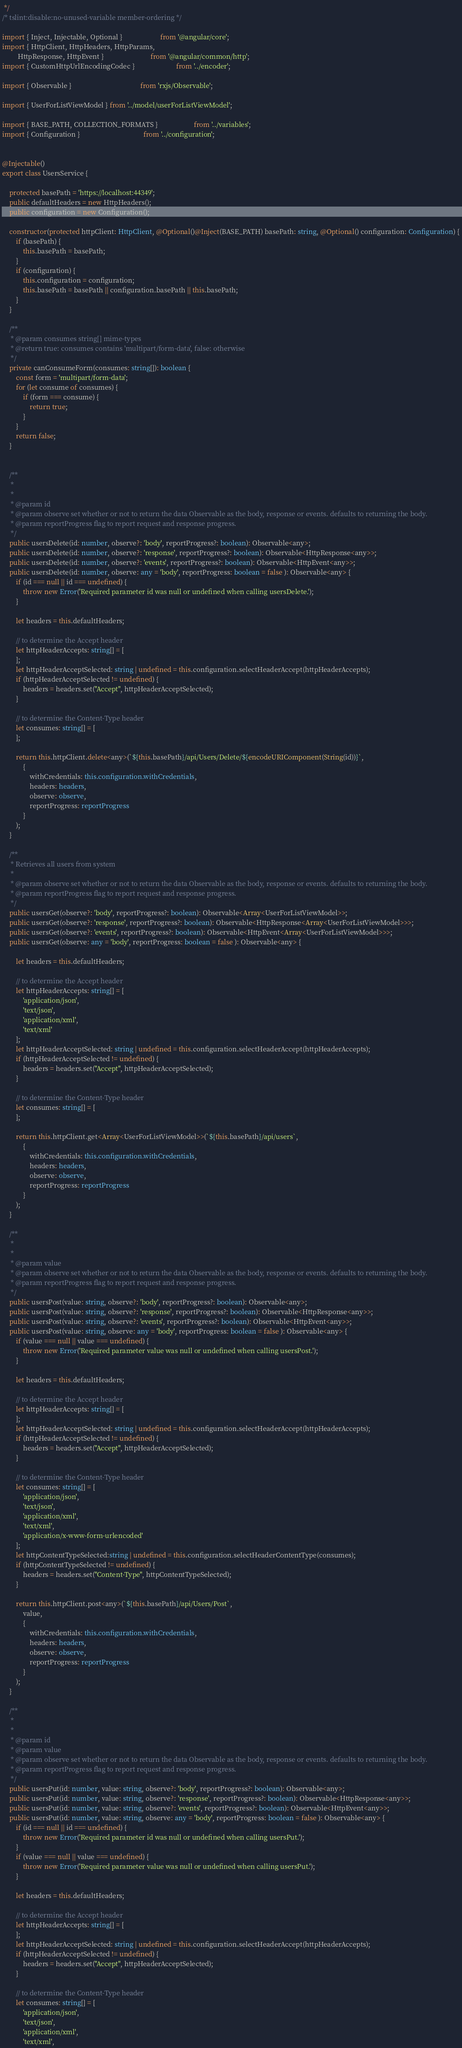Convert code to text. <code><loc_0><loc_0><loc_500><loc_500><_TypeScript_> */
/* tslint:disable:no-unused-variable member-ordering */

import { Inject, Injectable, Optional }                      from '@angular/core';
import { HttpClient, HttpHeaders, HttpParams,
         HttpResponse, HttpEvent }                           from '@angular/common/http';
import { CustomHttpUrlEncodingCodec }                        from '../encoder';

import { Observable }                                        from 'rxjs/Observable';

import { UserForListViewModel } from '../model/userForListViewModel';

import { BASE_PATH, COLLECTION_FORMATS }                     from '../variables';
import { Configuration }                                     from '../configuration';


@Injectable()
export class UsersService {

    protected basePath = 'https://localhost:44349';
    public defaultHeaders = new HttpHeaders();
    public configuration = new Configuration();

    constructor(protected httpClient: HttpClient, @Optional()@Inject(BASE_PATH) basePath: string, @Optional() configuration: Configuration) {
        if (basePath) {
            this.basePath = basePath;
        }
        if (configuration) {
            this.configuration = configuration;
            this.basePath = basePath || configuration.basePath || this.basePath;
        }
    }

    /**
     * @param consumes string[] mime-types
     * @return true: consumes contains 'multipart/form-data', false: otherwise
     */
    private canConsumeForm(consumes: string[]): boolean {
        const form = 'multipart/form-data';
        for (let consume of consumes) {
            if (form === consume) {
                return true;
            }
        }
        return false;
    }


    /**
     * 
     * 
     * @param id 
     * @param observe set whether or not to return the data Observable as the body, response or events. defaults to returning the body.
     * @param reportProgress flag to report request and response progress.
     */
    public usersDelete(id: number, observe?: 'body', reportProgress?: boolean): Observable<any>;
    public usersDelete(id: number, observe?: 'response', reportProgress?: boolean): Observable<HttpResponse<any>>;
    public usersDelete(id: number, observe?: 'events', reportProgress?: boolean): Observable<HttpEvent<any>>;
    public usersDelete(id: number, observe: any = 'body', reportProgress: boolean = false ): Observable<any> {
        if (id === null || id === undefined) {
            throw new Error('Required parameter id was null or undefined when calling usersDelete.');
        }

        let headers = this.defaultHeaders;

        // to determine the Accept header
        let httpHeaderAccepts: string[] = [
        ];
        let httpHeaderAcceptSelected: string | undefined = this.configuration.selectHeaderAccept(httpHeaderAccepts);
        if (httpHeaderAcceptSelected != undefined) {
            headers = headers.set("Accept", httpHeaderAcceptSelected);
        }

        // to determine the Content-Type header
        let consumes: string[] = [
        ];

        return this.httpClient.delete<any>(`${this.basePath}/api/Users/Delete/${encodeURIComponent(String(id))}`,
            {
                withCredentials: this.configuration.withCredentials,
                headers: headers,
                observe: observe,
                reportProgress: reportProgress
            }
        );
    }

    /**
     * Retrieves all users from system
     * 
     * @param observe set whether or not to return the data Observable as the body, response or events. defaults to returning the body.
     * @param reportProgress flag to report request and response progress.
     */
    public usersGet(observe?: 'body', reportProgress?: boolean): Observable<Array<UserForListViewModel>>;
    public usersGet(observe?: 'response', reportProgress?: boolean): Observable<HttpResponse<Array<UserForListViewModel>>>;
    public usersGet(observe?: 'events', reportProgress?: boolean): Observable<HttpEvent<Array<UserForListViewModel>>>;
    public usersGet(observe: any = 'body', reportProgress: boolean = false ): Observable<any> {

        let headers = this.defaultHeaders;

        // to determine the Accept header
        let httpHeaderAccepts: string[] = [
            'application/json',
            'text/json',
            'application/xml',
            'text/xml'
        ];
        let httpHeaderAcceptSelected: string | undefined = this.configuration.selectHeaderAccept(httpHeaderAccepts);
        if (httpHeaderAcceptSelected != undefined) {
            headers = headers.set("Accept", httpHeaderAcceptSelected);
        }

        // to determine the Content-Type header
        let consumes: string[] = [
        ];

        return this.httpClient.get<Array<UserForListViewModel>>(`${this.basePath}/api/users`,
            {
                withCredentials: this.configuration.withCredentials,
                headers: headers,
                observe: observe,
                reportProgress: reportProgress
            }
        );
    }

    /**
     * 
     * 
     * @param value 
     * @param observe set whether or not to return the data Observable as the body, response or events. defaults to returning the body.
     * @param reportProgress flag to report request and response progress.
     */
    public usersPost(value: string, observe?: 'body', reportProgress?: boolean): Observable<any>;
    public usersPost(value: string, observe?: 'response', reportProgress?: boolean): Observable<HttpResponse<any>>;
    public usersPost(value: string, observe?: 'events', reportProgress?: boolean): Observable<HttpEvent<any>>;
    public usersPost(value: string, observe: any = 'body', reportProgress: boolean = false ): Observable<any> {
        if (value === null || value === undefined) {
            throw new Error('Required parameter value was null or undefined when calling usersPost.');
        }

        let headers = this.defaultHeaders;

        // to determine the Accept header
        let httpHeaderAccepts: string[] = [
        ];
        let httpHeaderAcceptSelected: string | undefined = this.configuration.selectHeaderAccept(httpHeaderAccepts);
        if (httpHeaderAcceptSelected != undefined) {
            headers = headers.set("Accept", httpHeaderAcceptSelected);
        }

        // to determine the Content-Type header
        let consumes: string[] = [
            'application/json',
            'text/json',
            'application/xml',
            'text/xml',
            'application/x-www-form-urlencoded'
        ];
        let httpContentTypeSelected:string | undefined = this.configuration.selectHeaderContentType(consumes);
        if (httpContentTypeSelected != undefined) {
            headers = headers.set("Content-Type", httpContentTypeSelected);
        }

        return this.httpClient.post<any>(`${this.basePath}/api/Users/Post`,
            value,
            {
                withCredentials: this.configuration.withCredentials,
                headers: headers,
                observe: observe,
                reportProgress: reportProgress
            }
        );
    }

    /**
     * 
     * 
     * @param id 
     * @param value 
     * @param observe set whether or not to return the data Observable as the body, response or events. defaults to returning the body.
     * @param reportProgress flag to report request and response progress.
     */
    public usersPut(id: number, value: string, observe?: 'body', reportProgress?: boolean): Observable<any>;
    public usersPut(id: number, value: string, observe?: 'response', reportProgress?: boolean): Observable<HttpResponse<any>>;
    public usersPut(id: number, value: string, observe?: 'events', reportProgress?: boolean): Observable<HttpEvent<any>>;
    public usersPut(id: number, value: string, observe: any = 'body', reportProgress: boolean = false ): Observable<any> {
        if (id === null || id === undefined) {
            throw new Error('Required parameter id was null or undefined when calling usersPut.');
        }
        if (value === null || value === undefined) {
            throw new Error('Required parameter value was null or undefined when calling usersPut.');
        }

        let headers = this.defaultHeaders;

        // to determine the Accept header
        let httpHeaderAccepts: string[] = [
        ];
        let httpHeaderAcceptSelected: string | undefined = this.configuration.selectHeaderAccept(httpHeaderAccepts);
        if (httpHeaderAcceptSelected != undefined) {
            headers = headers.set("Accept", httpHeaderAcceptSelected);
        }

        // to determine the Content-Type header
        let consumes: string[] = [
            'application/json',
            'text/json',
            'application/xml',
            'text/xml',</code> 